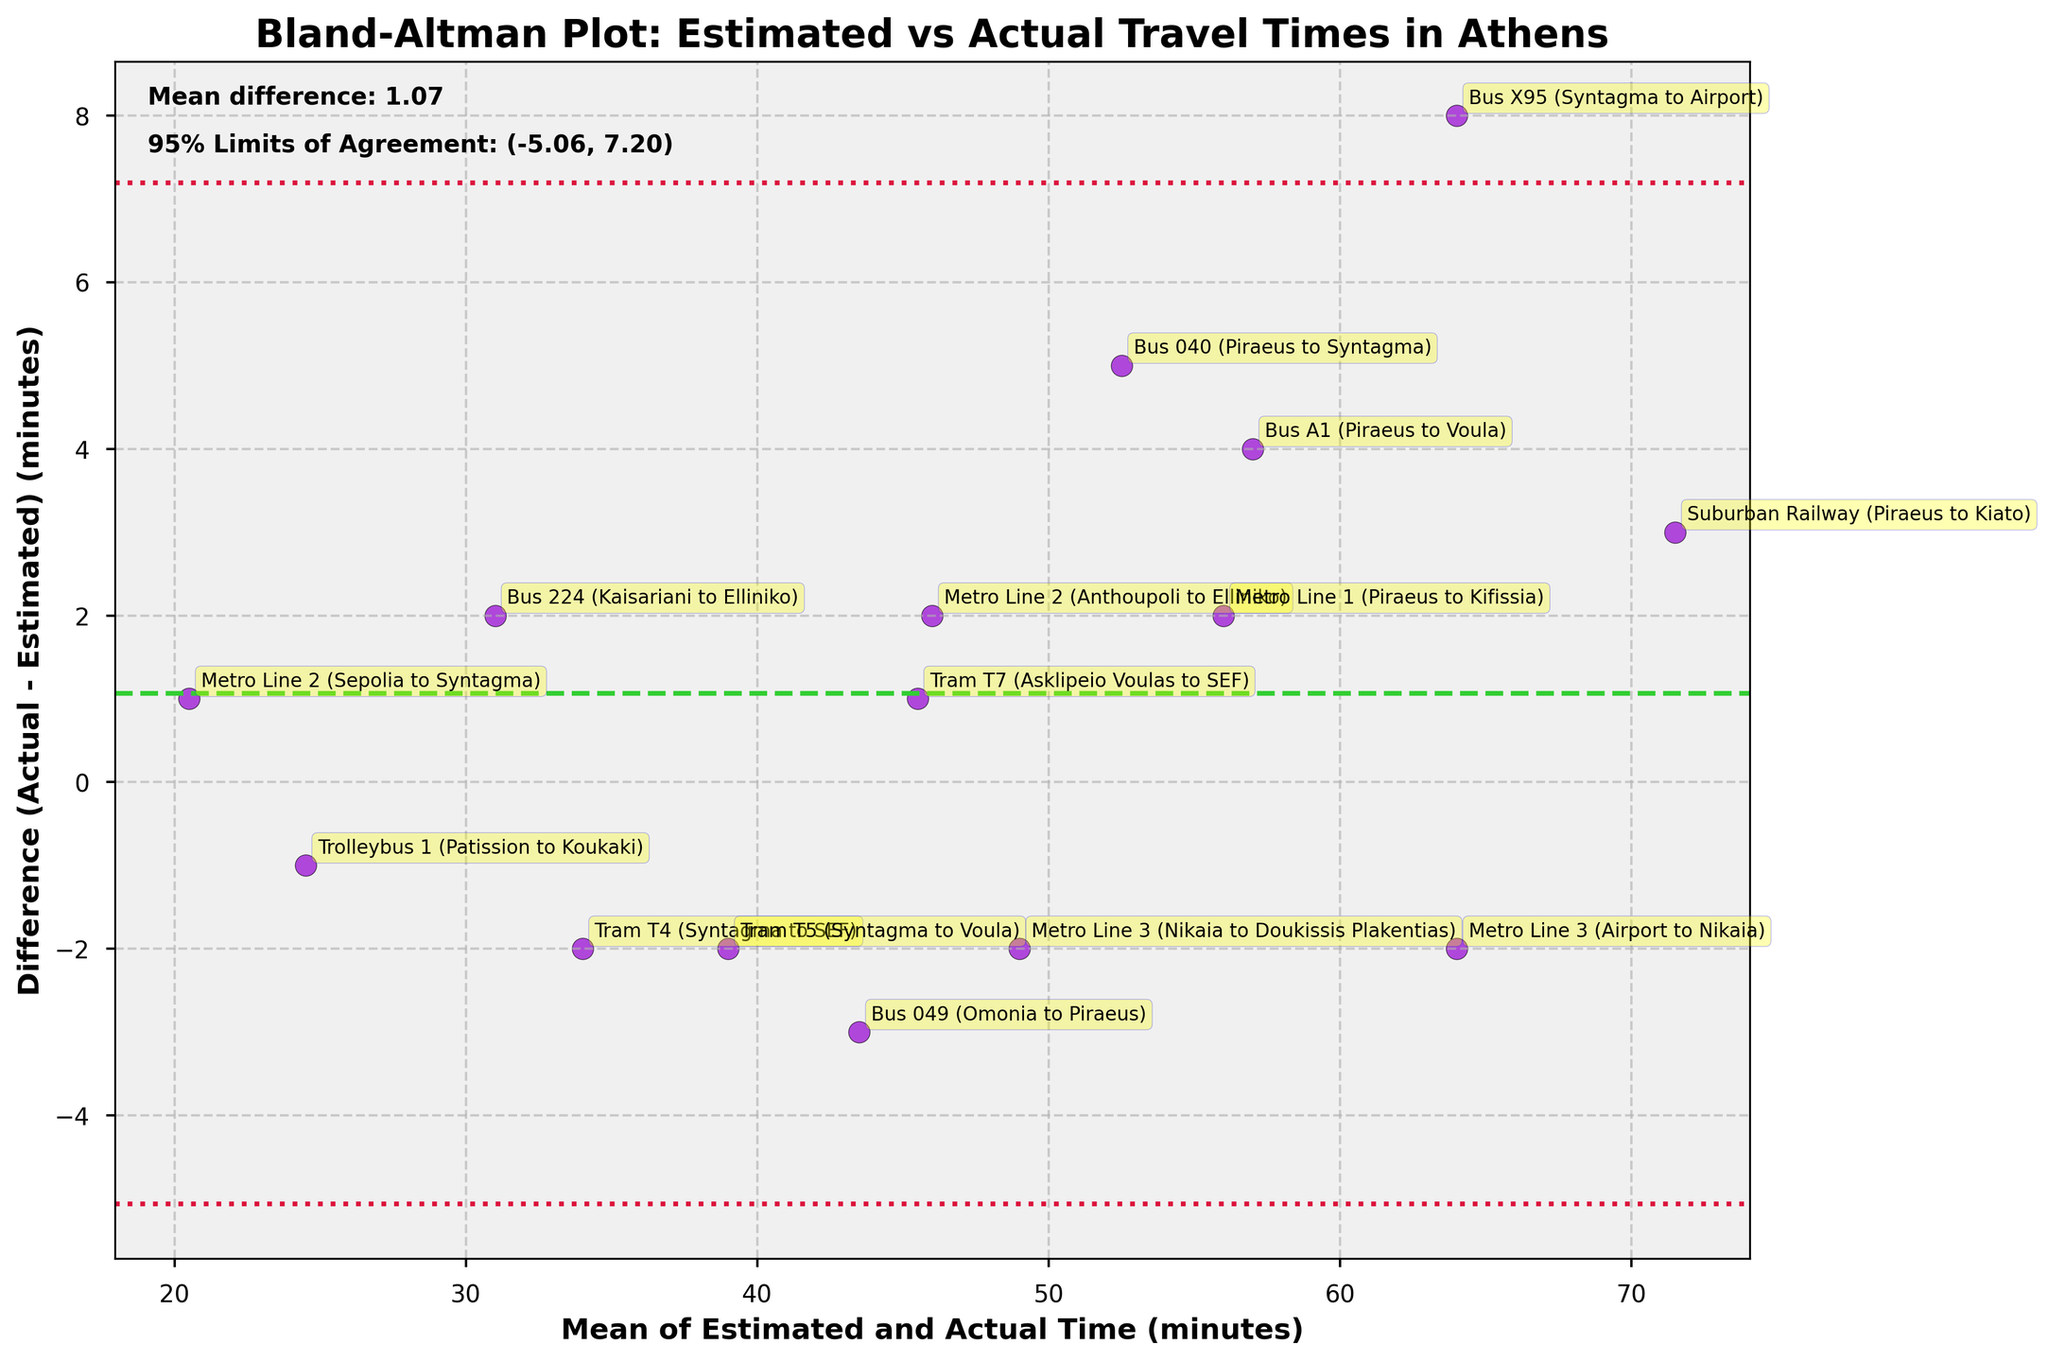How many data points are plotted in the figure? By counting the number of route names annotated on the plot, we find that there are 15 data points.
Answer: 15 What is the mean difference between estimated and actual travel times marked in the plot? The mean difference is stated on the plot as a text annotation in the upper-left corner. It reads, 'Mean difference: 1.27'.
Answer: 1.27 What is the range of the 95% Limits of Agreement in the plot? The 95% Limits of Agreement are annotated on the plot as text in the upper-left corner. It reads, '95% Limits of Agreement: (-6.80, 9.34)'.
Answer: (-6.80, 9.34) Which route has the highest positive difference (actual time is much greater than estimated)? The data point with the highest value on the y-axis (vertical distance from the mean line) will indicate this route. This is Bus X95 (Syntagma to Airport), as it is the highest point above the zero difference line.
Answer: Bus X95 (Syntagma to Airport) Are there more routes where the actual travel time is less than the estimated travel time or more where the actual time is greater? By counting the data points above and below the mean difference line (y-axis=0), we can determine this. There are more points below the line, indicating actual travel time is less than estimated for more routes.
Answer: Less Which route has the smallest difference between estimated and actual travel times? Identifying the data point closest to the mean difference line (y-axis=0) identifies this. Metro Line 3 (Airport to Nikaia) is closest to the mean difference line.
Answer: Metro Line 3 (Airport to Nikaia) What could be inferred from the positioning of tram routes (T4, T5, T7) in terms of their estimation accuracy? By analyzing the positions of tram routes, T4 and T5 are below the zero line indicating that actual times were less than estimated, while T7 is slightly above the zero line suggesting its estimate was fairly accurate.
Answer: T4, T5 underestimated; T7 accurate What is the distance between the mean difference line and the lower limit of agreement? The distance is calculated by subtracting the lower limit from the mean difference. Mean difference = 1.27, Lower limit = -6.80, so the distance is 1.27 - (-6.80).
Answer: 8.07 Between buses and metro routes, which category shows greater variability in the difference between estimated and actual travel times? By visually comparing the spread of data points for buses and metro routes, it appears that the bus routes have a wider spread (more variability).
Answer: Buses Which route has an actual travel time closest to its estimated travel time? This is the route whose annotated point is closest to the mean difference line (y-axis = 0). This route is the Metro Line 3 (Airport to Nikaia).
Answer: Metro Line 3 (Airport to Nikaia) 